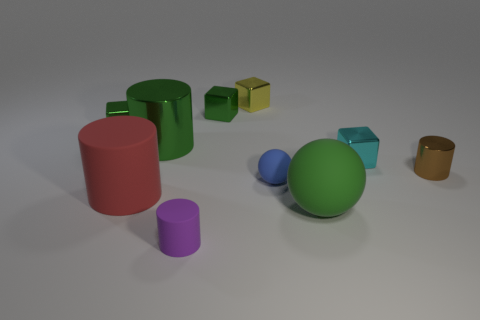Subtract all cylinders. How many objects are left? 6 Add 1 tiny purple metal cubes. How many tiny purple metal cubes exist? 1 Subtract all blue balls. How many balls are left? 1 Subtract all green cylinders. How many cylinders are left? 3 Subtract 1 cyan blocks. How many objects are left? 9 Subtract 3 blocks. How many blocks are left? 1 Subtract all cyan cylinders. Subtract all brown cubes. How many cylinders are left? 4 Subtract all gray cylinders. How many green cubes are left? 2 Subtract all matte cylinders. Subtract all big purple cylinders. How many objects are left? 8 Add 1 red rubber things. How many red rubber things are left? 2 